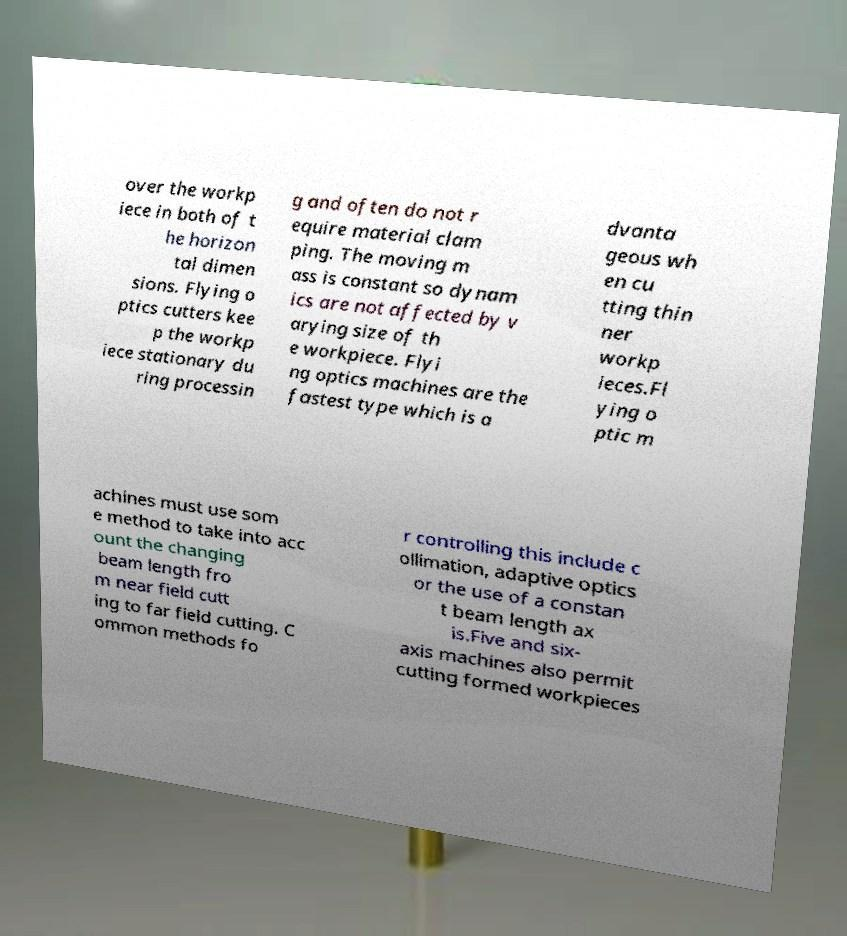What messages or text are displayed in this image? I need them in a readable, typed format. over the workp iece in both of t he horizon tal dimen sions. Flying o ptics cutters kee p the workp iece stationary du ring processin g and often do not r equire material clam ping. The moving m ass is constant so dynam ics are not affected by v arying size of th e workpiece. Flyi ng optics machines are the fastest type which is a dvanta geous wh en cu tting thin ner workp ieces.Fl ying o ptic m achines must use som e method to take into acc ount the changing beam length fro m near field cutt ing to far field cutting. C ommon methods fo r controlling this include c ollimation, adaptive optics or the use of a constan t beam length ax is.Five and six- axis machines also permit cutting formed workpieces 